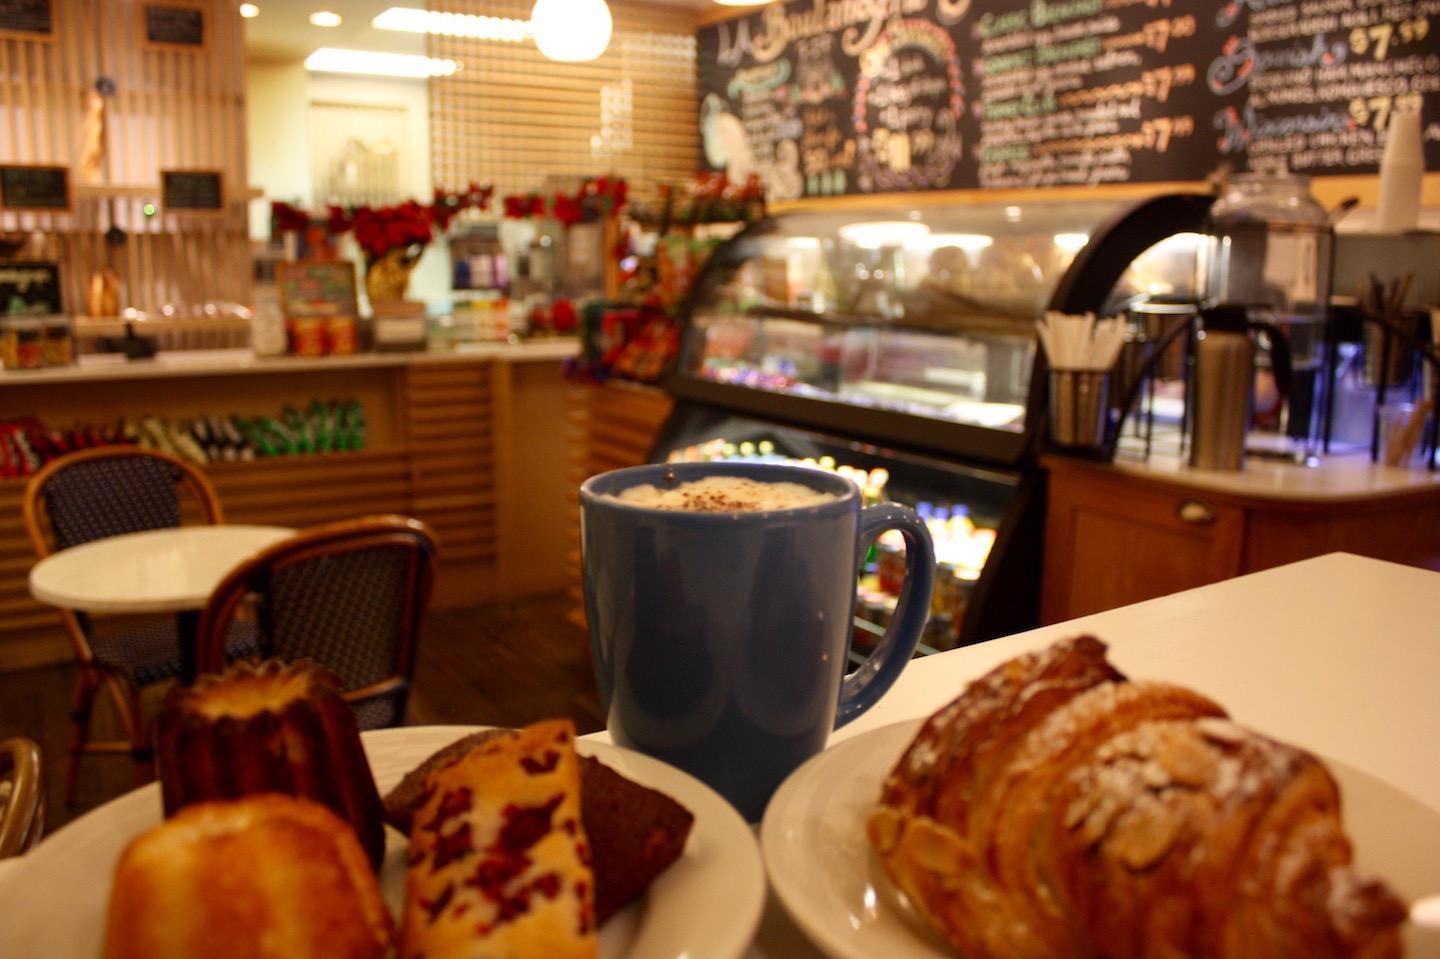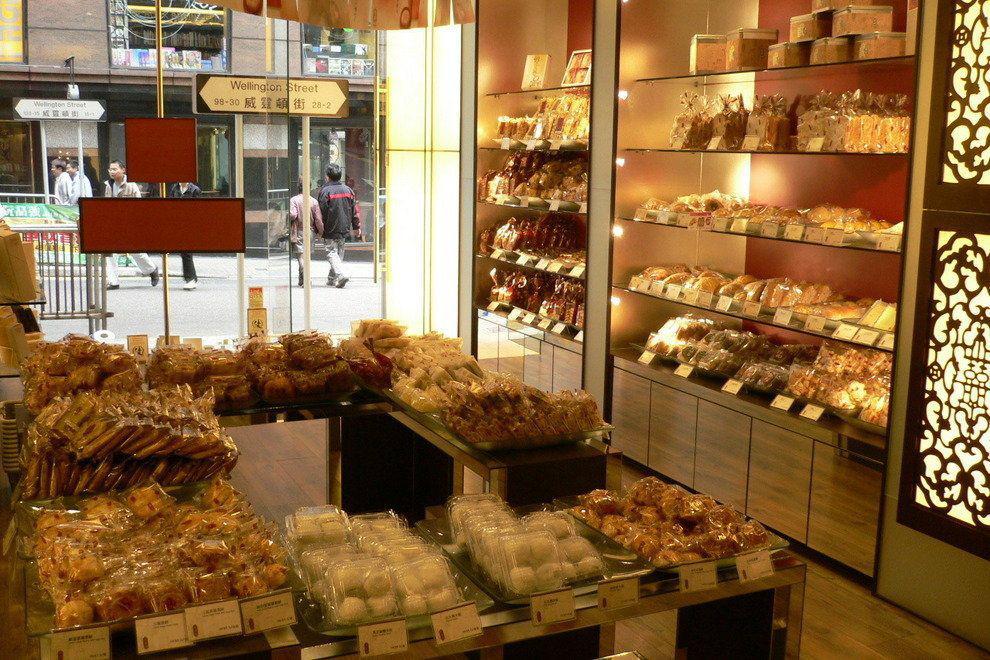The first image is the image on the left, the second image is the image on the right. Evaluate the accuracy of this statement regarding the images: "In each image, a bakery cafe has its menu posted on one or more black boards, but table seating is seen in only one image.". Is it true? Answer yes or no. No. 